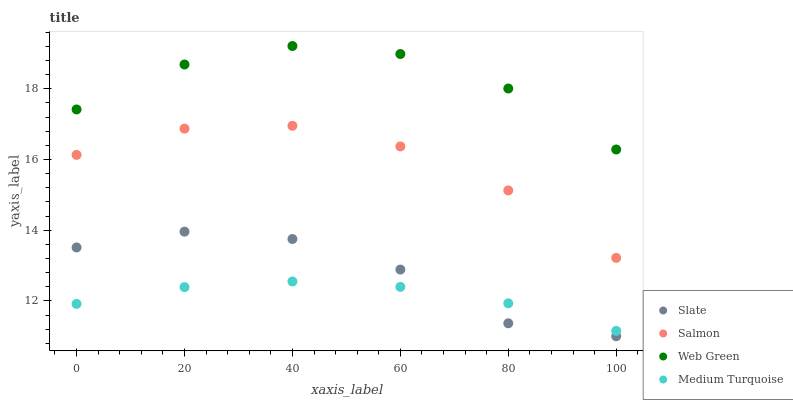Does Medium Turquoise have the minimum area under the curve?
Answer yes or no. Yes. Does Web Green have the maximum area under the curve?
Answer yes or no. Yes. Does Salmon have the minimum area under the curve?
Answer yes or no. No. Does Salmon have the maximum area under the curve?
Answer yes or no. No. Is Medium Turquoise the smoothest?
Answer yes or no. Yes. Is Slate the roughest?
Answer yes or no. Yes. Is Salmon the smoothest?
Answer yes or no. No. Is Salmon the roughest?
Answer yes or no. No. Does Slate have the lowest value?
Answer yes or no. Yes. Does Salmon have the lowest value?
Answer yes or no. No. Does Web Green have the highest value?
Answer yes or no. Yes. Does Salmon have the highest value?
Answer yes or no. No. Is Salmon less than Web Green?
Answer yes or no. Yes. Is Web Green greater than Slate?
Answer yes or no. Yes. Does Slate intersect Medium Turquoise?
Answer yes or no. Yes. Is Slate less than Medium Turquoise?
Answer yes or no. No. Is Slate greater than Medium Turquoise?
Answer yes or no. No. Does Salmon intersect Web Green?
Answer yes or no. No. 